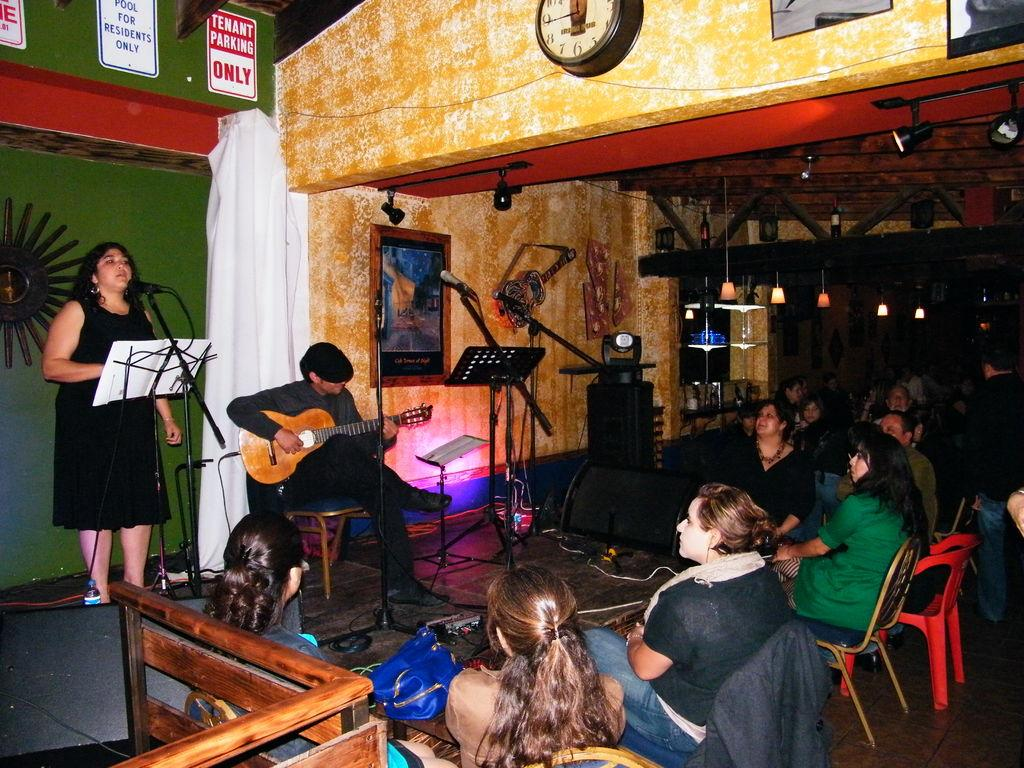What are the people in the image doing? There are people sitting on chairs in the image. What is happening on the stage in the image? There is a woman standing on a stage and a man sitting on the stage in the image. What is the man on the stage holding? The man on the stage is holding a guitar in his hand. What type of list is being read out during the competition in the image? There is no competition or list present in the image. What class is the woman teaching on the stage in the image? There is no class or teacher-student interaction depicted in the image. 